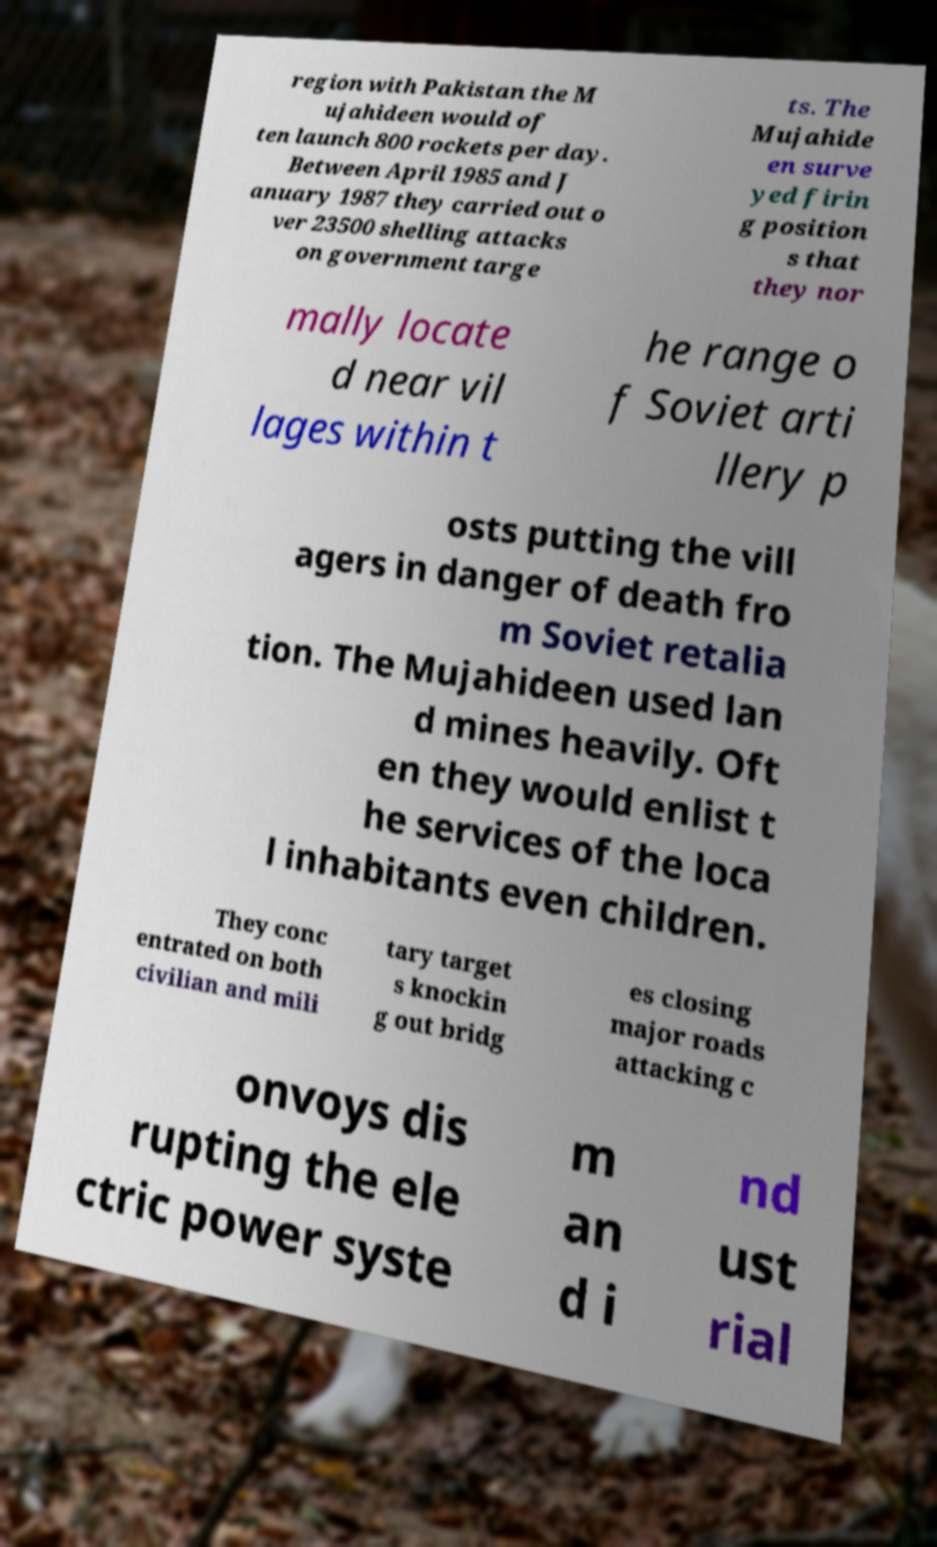Can you accurately transcribe the text from the provided image for me? region with Pakistan the M ujahideen would of ten launch 800 rockets per day. Between April 1985 and J anuary 1987 they carried out o ver 23500 shelling attacks on government targe ts. The Mujahide en surve yed firin g position s that they nor mally locate d near vil lages within t he range o f Soviet arti llery p osts putting the vill agers in danger of death fro m Soviet retalia tion. The Mujahideen used lan d mines heavily. Oft en they would enlist t he services of the loca l inhabitants even children. They conc entrated on both civilian and mili tary target s knockin g out bridg es closing major roads attacking c onvoys dis rupting the ele ctric power syste m an d i nd ust rial 